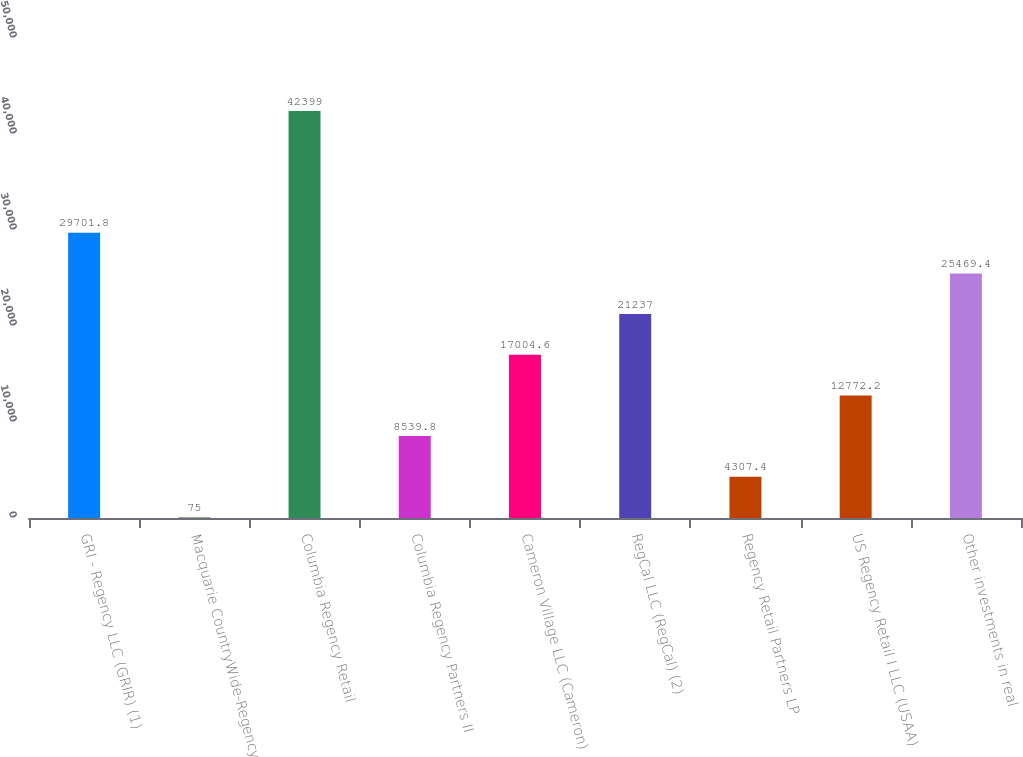Convert chart to OTSL. <chart><loc_0><loc_0><loc_500><loc_500><bar_chart><fcel>GRI - Regency LLC (GRIR) (1)<fcel>Macquarie CountryWide-Regency<fcel>Columbia Regency Retail<fcel>Columbia Regency Partners II<fcel>Cameron Village LLC (Cameron)<fcel>RegCal LLC (RegCal) (2)<fcel>Regency Retail Partners LP<fcel>US Regency Retail I LLC (USAA)<fcel>Other investments in real<nl><fcel>29701.8<fcel>75<fcel>42399<fcel>8539.8<fcel>17004.6<fcel>21237<fcel>4307.4<fcel>12772.2<fcel>25469.4<nl></chart> 